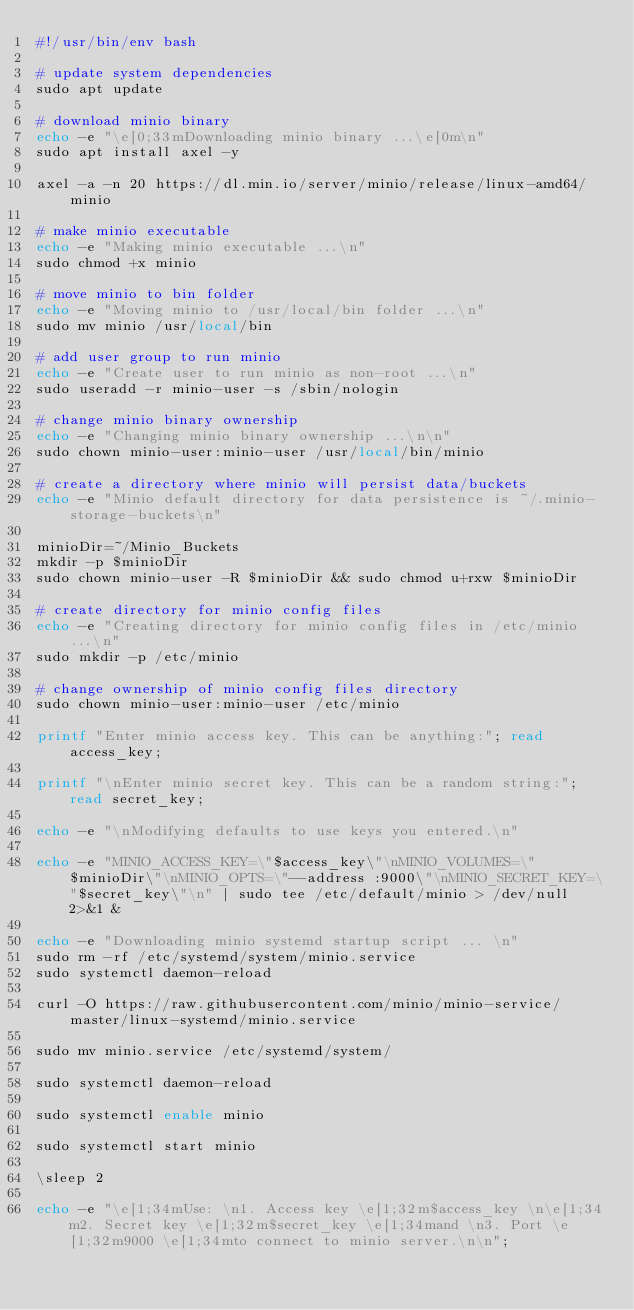<code> <loc_0><loc_0><loc_500><loc_500><_Bash_>#!/usr/bin/env bash

# update system dependencies
sudo apt update

# download minio binary
echo -e "\e[0;33mDownloading minio binary ...\e[0m\n"
sudo apt install axel -y

axel -a -n 20 https://dl.min.io/server/minio/release/linux-amd64/minio

# make minio executable
echo -e "Making minio executable ...\n"
sudo chmod +x minio

# move minio to bin folder
echo -e "Moving minio to /usr/local/bin folder ...\n"
sudo mv minio /usr/local/bin

# add user group to run minio
echo -e "Create user to run minio as non-root ...\n"
sudo useradd -r minio-user -s /sbin/nologin

# change minio binary ownership
echo -e "Changing minio binary ownership ...\n\n"
sudo chown minio-user:minio-user /usr/local/bin/minio

# create a directory where minio will persist data/buckets
echo -e "Minio default directory for data persistence is ~/.minio-storage-buckets\n"

minioDir=~/Minio_Buckets
mkdir -p $minioDir
sudo chown minio-user -R $minioDir && sudo chmod u+rxw $minioDir

# create directory for minio config files
echo -e "Creating directory for minio config files in /etc/minio ...\n"
sudo mkdir -p /etc/minio

# change ownership of minio config files directory
sudo chown minio-user:minio-user /etc/minio

printf "Enter minio access key. This can be anything:"; read access_key;

printf "\nEnter minio secret key. This can be a random string:"; read secret_key;

echo -e "\nModifying defaults to use keys you entered.\n"

echo -e "MINIO_ACCESS_KEY=\"$access_key\"\nMINIO_VOLUMES=\"$minioDir\"\nMINIO_OPTS=\"--address :9000\"\nMINIO_SECRET_KEY=\"$secret_key\"\n" | sudo tee /etc/default/minio > /dev/null 2>&1 &

echo -e "Downloading minio systemd startup script ... \n"
sudo rm -rf /etc/systemd/system/minio.service
sudo systemctl daemon-reload

curl -O https://raw.githubusercontent.com/minio/minio-service/master/linux-systemd/minio.service

sudo mv minio.service /etc/systemd/system/

sudo systemctl daemon-reload

sudo systemctl enable minio

sudo systemctl start minio

\sleep 2

echo -e "\e[1;34mUse: \n1. Access key \e[1;32m$access_key \n\e[1;34m2. Secret key \e[1;32m$secret_key \e[1;34mand \n3. Port \e[1;32m9000 \e[1;34mto connect to minio server.\n\n";
</code> 